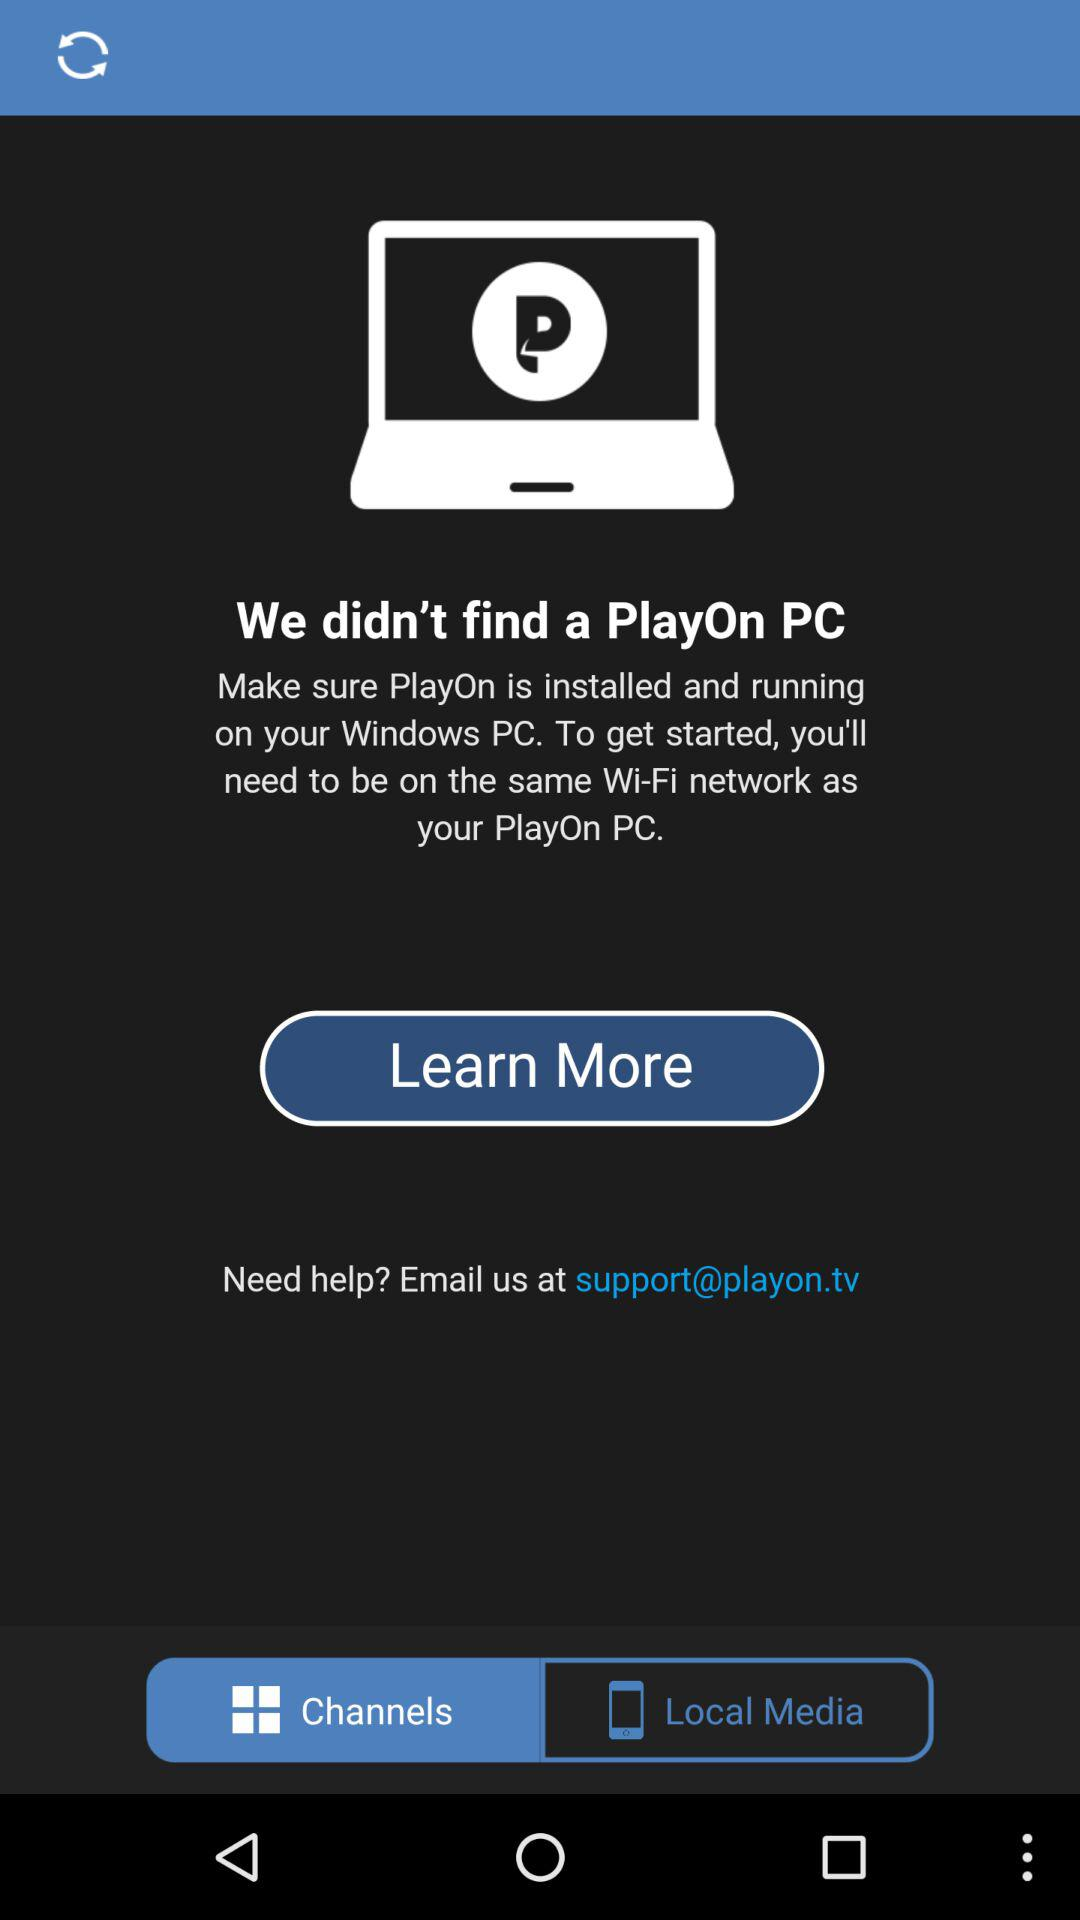What is the selected tab? The selected tab is "Channels". 